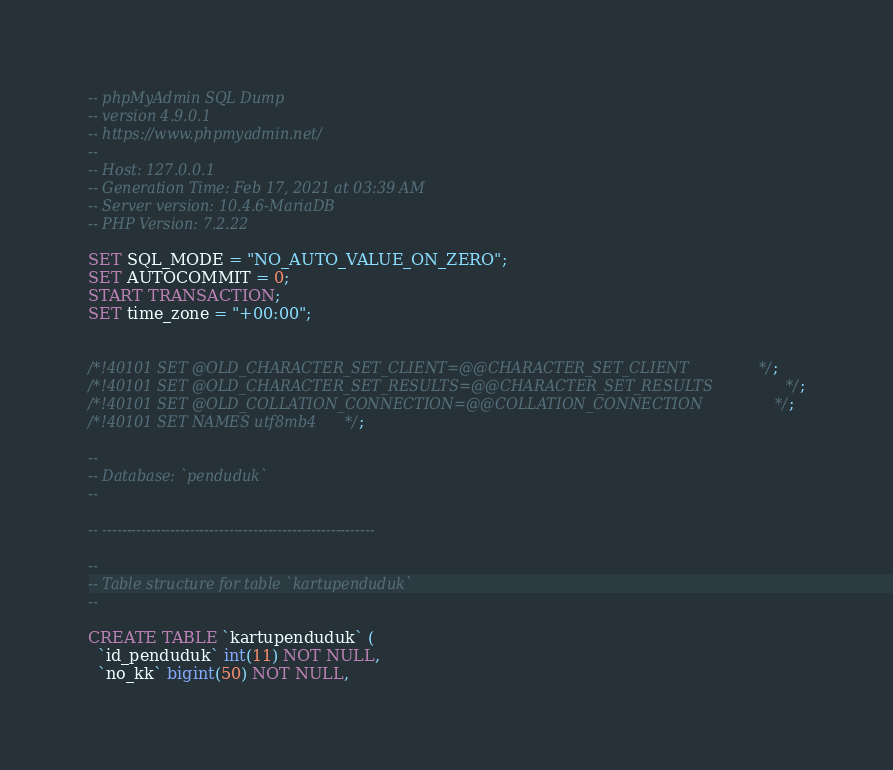Convert code to text. <code><loc_0><loc_0><loc_500><loc_500><_SQL_>-- phpMyAdmin SQL Dump
-- version 4.9.0.1
-- https://www.phpmyadmin.net/
--
-- Host: 127.0.0.1
-- Generation Time: Feb 17, 2021 at 03:39 AM
-- Server version: 10.4.6-MariaDB
-- PHP Version: 7.2.22

SET SQL_MODE = "NO_AUTO_VALUE_ON_ZERO";
SET AUTOCOMMIT = 0;
START TRANSACTION;
SET time_zone = "+00:00";


/*!40101 SET @OLD_CHARACTER_SET_CLIENT=@@CHARACTER_SET_CLIENT */;
/*!40101 SET @OLD_CHARACTER_SET_RESULTS=@@CHARACTER_SET_RESULTS */;
/*!40101 SET @OLD_COLLATION_CONNECTION=@@COLLATION_CONNECTION */;
/*!40101 SET NAMES utf8mb4 */;

--
-- Database: `penduduk`
--

-- --------------------------------------------------------

--
-- Table structure for table `kartupenduduk`
--

CREATE TABLE `kartupenduduk` (
  `id_penduduk` int(11) NOT NULL,
  `no_kk` bigint(50) NOT NULL,</code> 